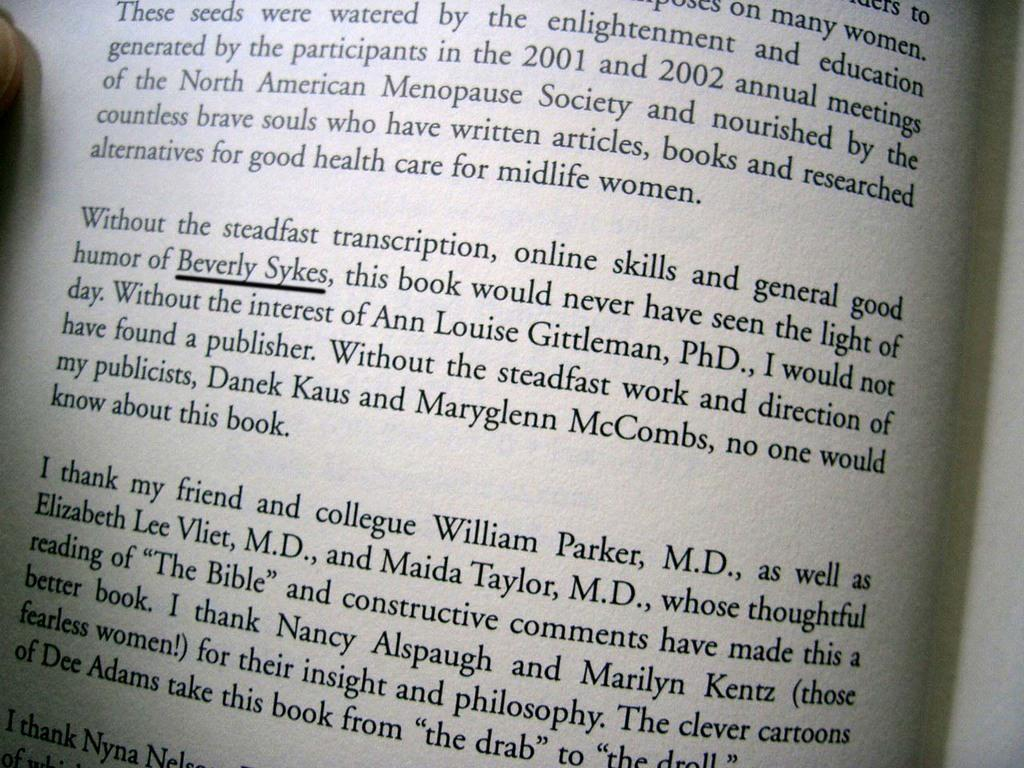<image>
Describe the image concisely. Open book on a page with the name Beverly Sykes underlined. 